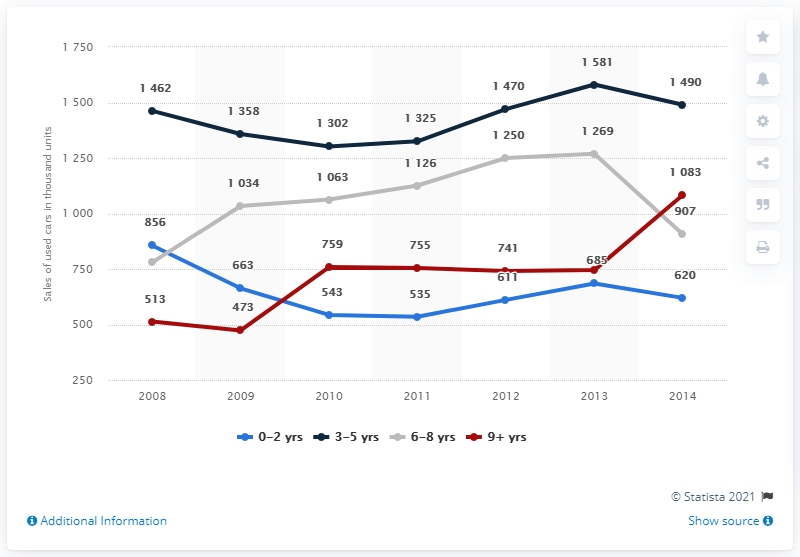List a handful of essential elements in this visual. There are four colored lines present. The increase in sales of cars in the most recent year was observed in the 9+ years age bracket of vehicles. 